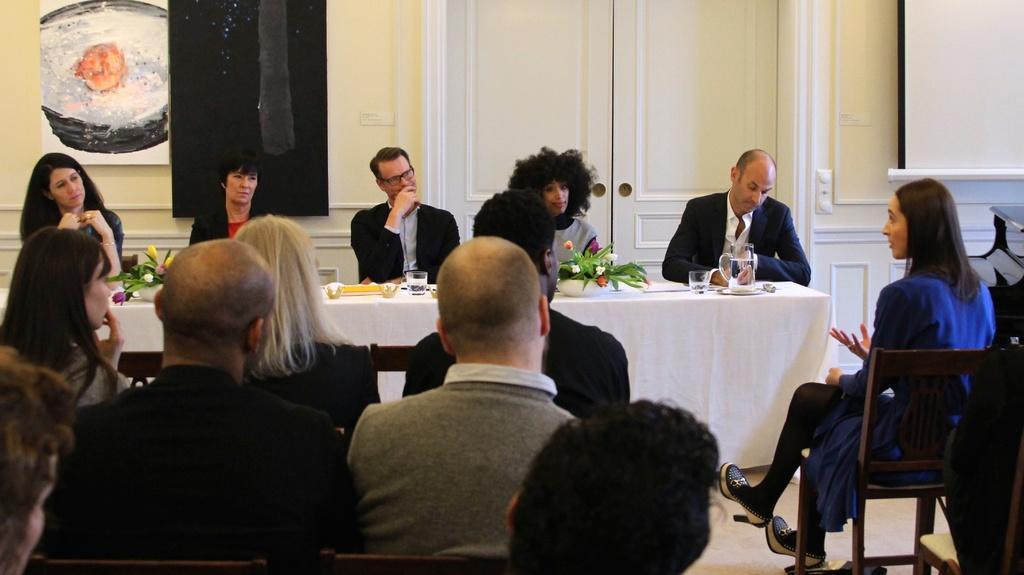Could you give a brief overview of what you see in this image? In this image there group of people who are sitting on a chair and on the top there is a wall and doors are there and in the middle there is one table and that table is covered with a white cloth and on that table there are glasses, cups, mugs, and one flower pot is there. 